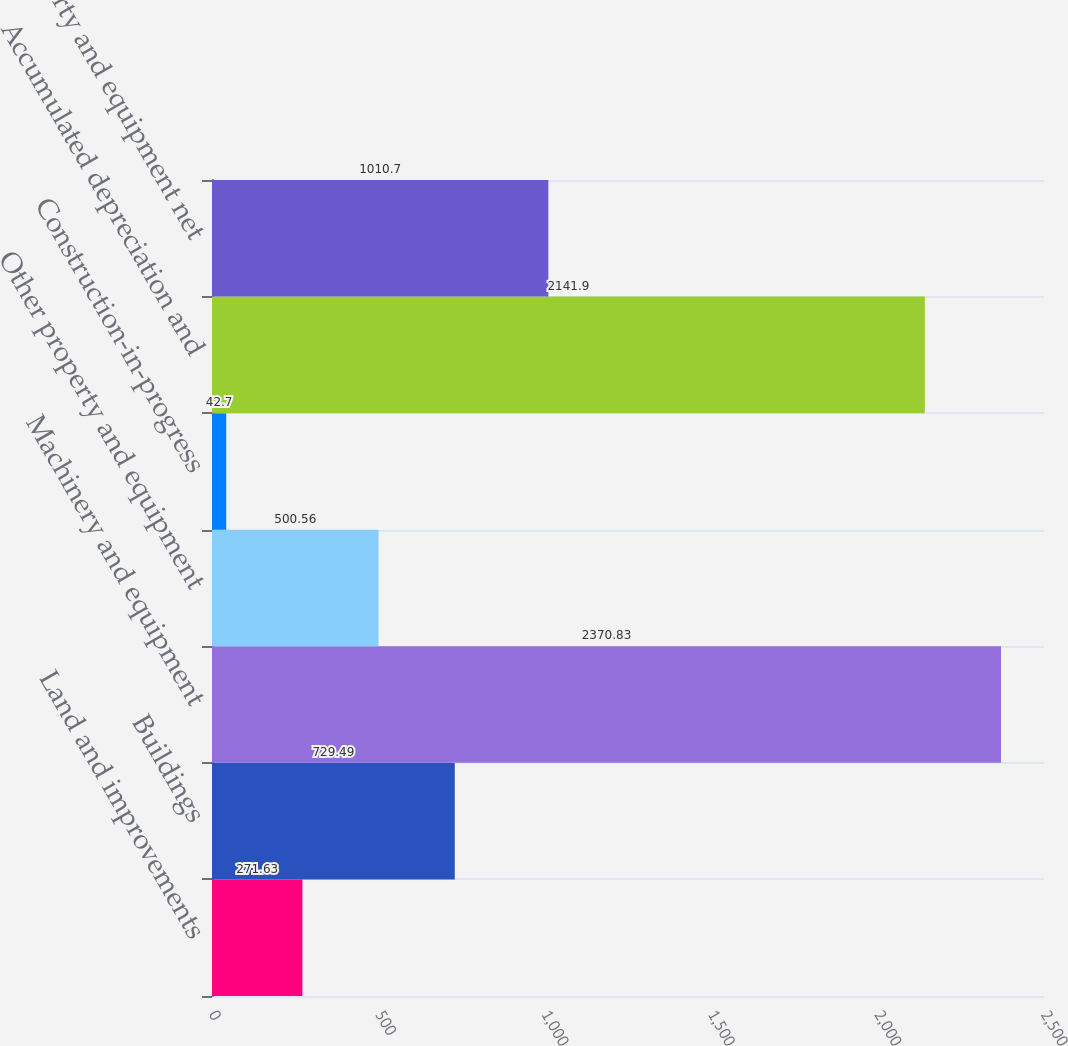Convert chart. <chart><loc_0><loc_0><loc_500><loc_500><bar_chart><fcel>Land and improvements<fcel>Buildings<fcel>Machinery and equipment<fcel>Other property and equipment<fcel>Construction-in-progress<fcel>Accumulated depreciation and<fcel>Property and equipment net<nl><fcel>271.63<fcel>729.49<fcel>2370.83<fcel>500.56<fcel>42.7<fcel>2141.9<fcel>1010.7<nl></chart> 